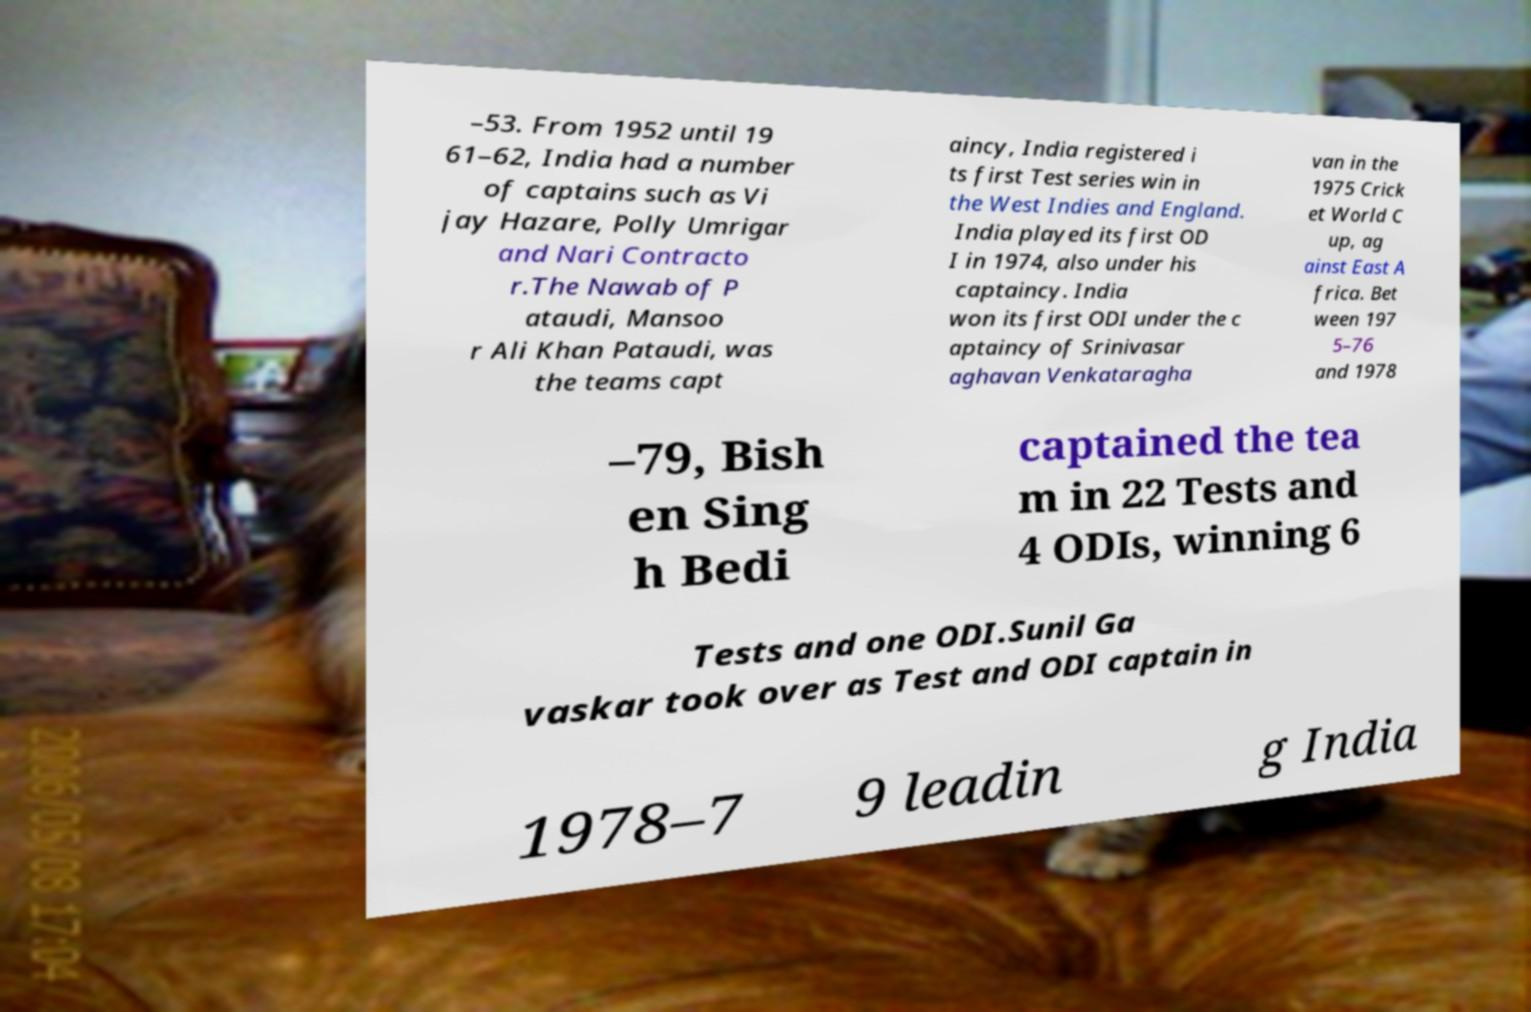Could you assist in decoding the text presented in this image and type it out clearly? –53. From 1952 until 19 61–62, India had a number of captains such as Vi jay Hazare, Polly Umrigar and Nari Contracto r.The Nawab of P ataudi, Mansoo r Ali Khan Pataudi, was the teams capt aincy, India registered i ts first Test series win in the West Indies and England. India played its first OD I in 1974, also under his captaincy. India won its first ODI under the c aptaincy of Srinivasar aghavan Venkataragha van in the 1975 Crick et World C up, ag ainst East A frica. Bet ween 197 5–76 and 1978 –79, Bish en Sing h Bedi captained the tea m in 22 Tests and 4 ODIs, winning 6 Tests and one ODI.Sunil Ga vaskar took over as Test and ODI captain in 1978–7 9 leadin g India 